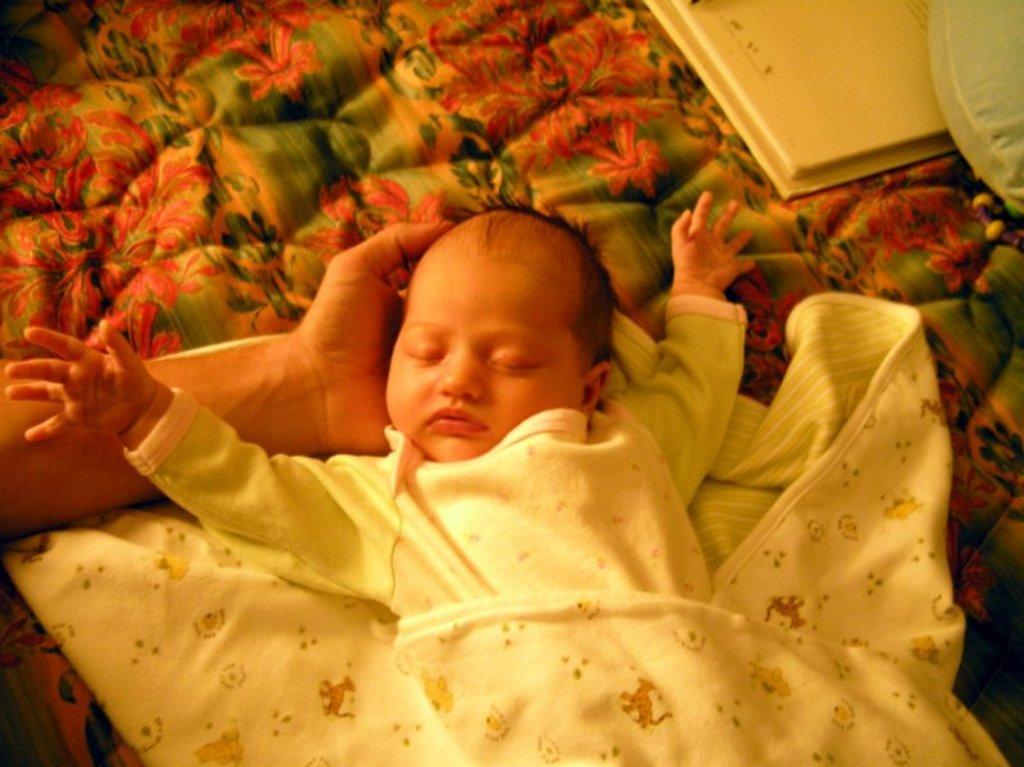Could you give a brief overview of what you see in this image? As we can see in the image there is a child wearing white color dress. There is a cloth, a person hand and here there is a white color cloth. 